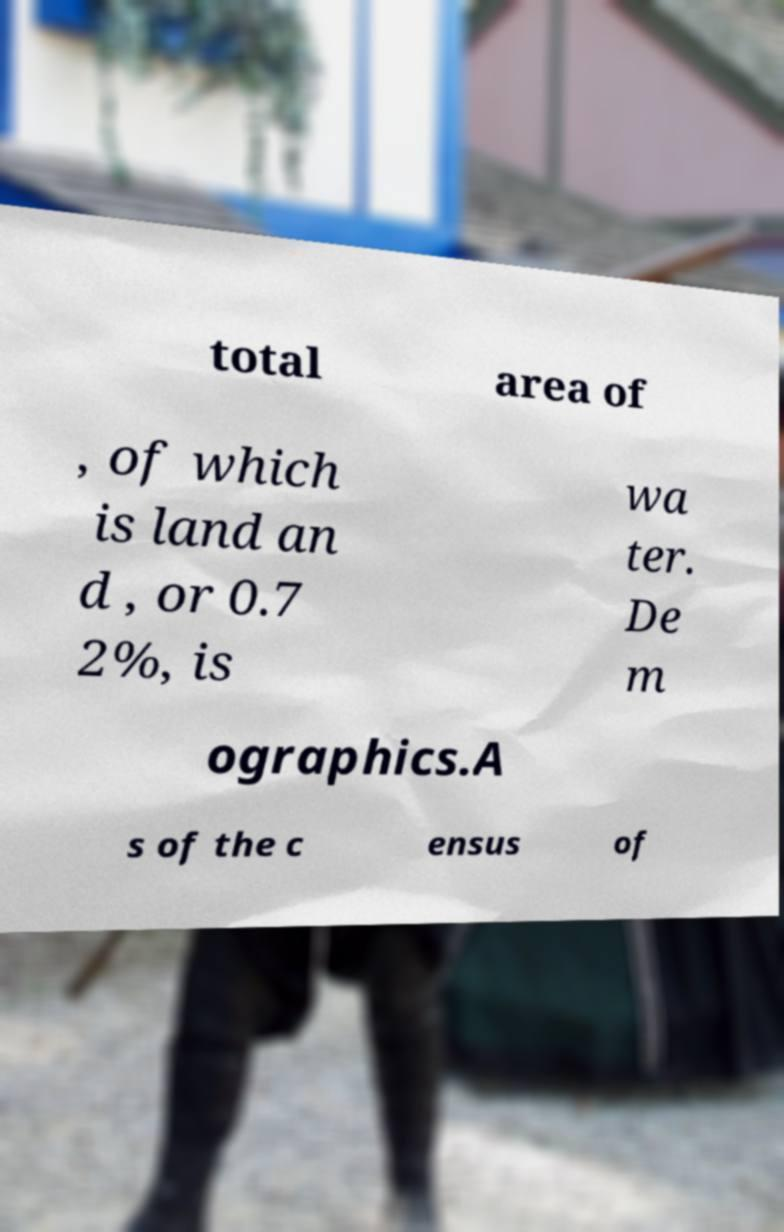Could you assist in decoding the text presented in this image and type it out clearly? total area of , of which is land an d , or 0.7 2%, is wa ter. De m ographics.A s of the c ensus of 